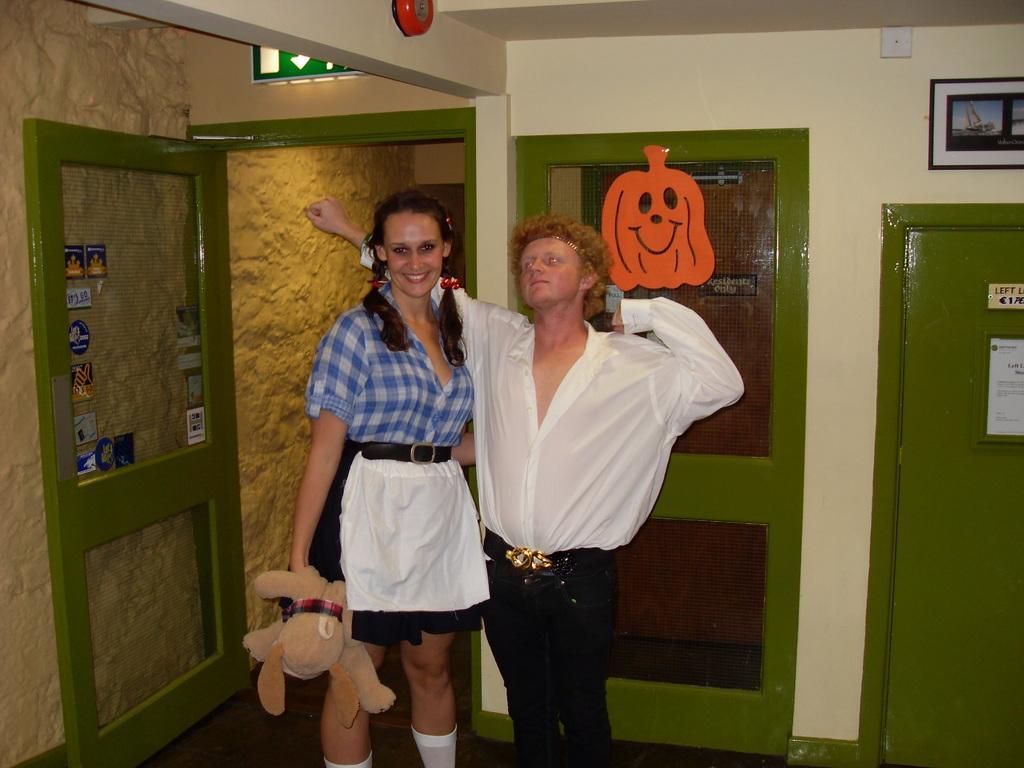Can you describe this image briefly? In this picture we can see two people and in the background we can see a wall, doors, posters and some objects. 